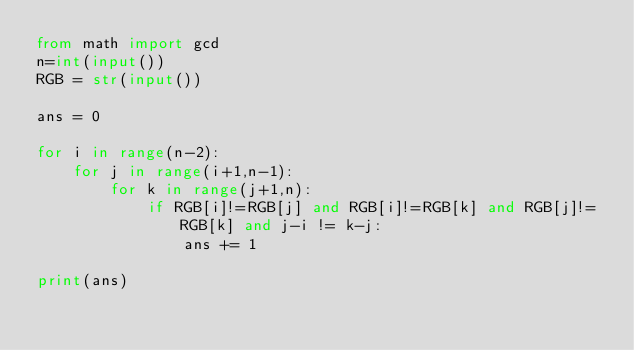<code> <loc_0><loc_0><loc_500><loc_500><_Python_>from math import gcd
n=int(input())
RGB = str(input())

ans = 0

for i in range(n-2):
    for j in range(i+1,n-1):
        for k in range(j+1,n):
            if RGB[i]!=RGB[j] and RGB[i]!=RGB[k] and RGB[j]!=RGB[k] and j-i != k-j:
                ans += 1

print(ans)    </code> 